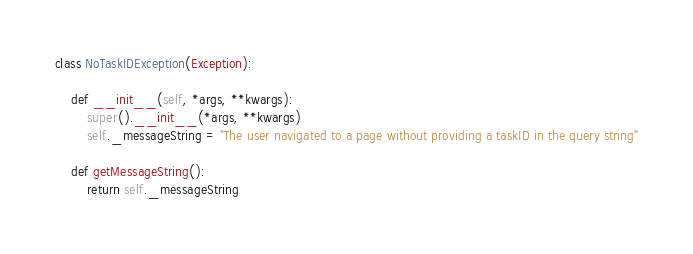<code> <loc_0><loc_0><loc_500><loc_500><_Python_>class NoTaskIDException(Exception):

    def __init__(self, *args, **kwargs):
        super().__init__(*args, **kwargs)
        self._messageString = "The user navigated to a page without providing a taskID in the query string"

    def getMessageString():
        return self._messageString</code> 